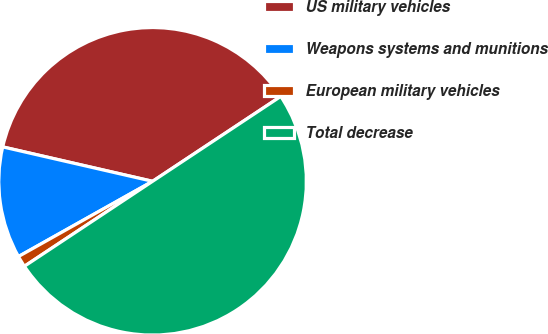Convert chart. <chart><loc_0><loc_0><loc_500><loc_500><pie_chart><fcel>US military vehicles<fcel>Weapons systems and munitions<fcel>European military vehicles<fcel>Total decrease<nl><fcel>37.1%<fcel>11.73%<fcel>1.18%<fcel>50.0%<nl></chart> 